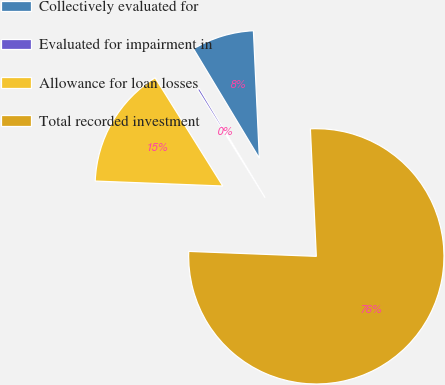Convert chart to OTSL. <chart><loc_0><loc_0><loc_500><loc_500><pie_chart><fcel>Collectively evaluated for<fcel>Evaluated for impairment in<fcel>Allowance for loan losses<fcel>Total recorded investment<nl><fcel>7.88%<fcel>0.27%<fcel>15.49%<fcel>76.36%<nl></chart> 